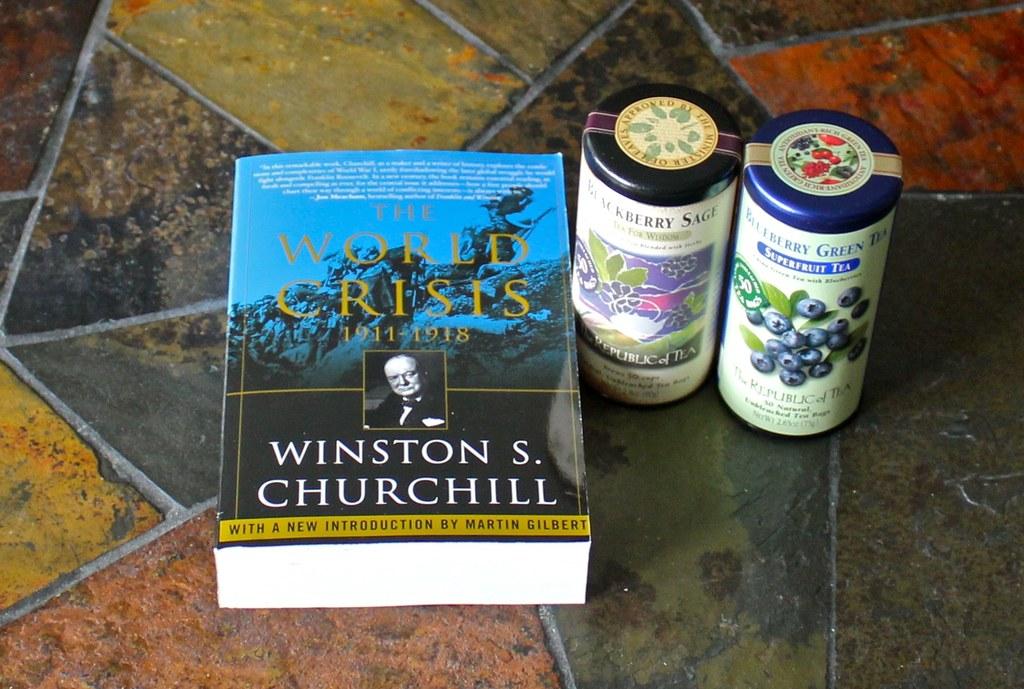What is the title of the book?
Provide a short and direct response. The world crisis. 